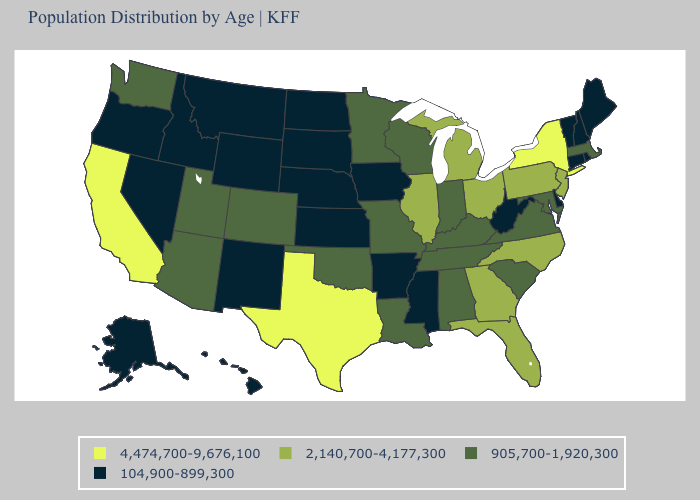Name the states that have a value in the range 4,474,700-9,676,100?
Quick response, please. California, New York, Texas. Does California have the highest value in the USA?
Give a very brief answer. Yes. What is the value of North Dakota?
Write a very short answer. 104,900-899,300. What is the lowest value in the USA?
Quick response, please. 104,900-899,300. What is the value of Illinois?
Keep it brief. 2,140,700-4,177,300. Is the legend a continuous bar?
Keep it brief. No. Which states have the lowest value in the USA?
Give a very brief answer. Alaska, Arkansas, Connecticut, Delaware, Hawaii, Idaho, Iowa, Kansas, Maine, Mississippi, Montana, Nebraska, Nevada, New Hampshire, New Mexico, North Dakota, Oregon, Rhode Island, South Dakota, Vermont, West Virginia, Wyoming. What is the value of Florida?
Keep it brief. 2,140,700-4,177,300. Does Florida have the lowest value in the South?
Answer briefly. No. What is the value of Louisiana?
Give a very brief answer. 905,700-1,920,300. Does California have the highest value in the West?
Answer briefly. Yes. What is the value of Wyoming?
Give a very brief answer. 104,900-899,300. Does the map have missing data?
Concise answer only. No. Name the states that have a value in the range 104,900-899,300?
Concise answer only. Alaska, Arkansas, Connecticut, Delaware, Hawaii, Idaho, Iowa, Kansas, Maine, Mississippi, Montana, Nebraska, Nevada, New Hampshire, New Mexico, North Dakota, Oregon, Rhode Island, South Dakota, Vermont, West Virginia, Wyoming. Does New Mexico have the lowest value in the USA?
Give a very brief answer. Yes. 